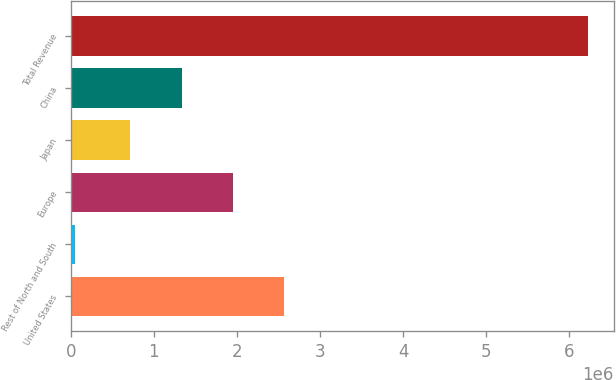Convert chart. <chart><loc_0><loc_0><loc_500><loc_500><bar_chart><fcel>United States<fcel>Rest of North and South<fcel>Europe<fcel>Japan<fcel>China<fcel>Total Revenue<nl><fcel>2.56837e+06<fcel>46276<fcel>1.95053e+06<fcel>714846<fcel>1.33269e+06<fcel>6.22469e+06<nl></chart> 